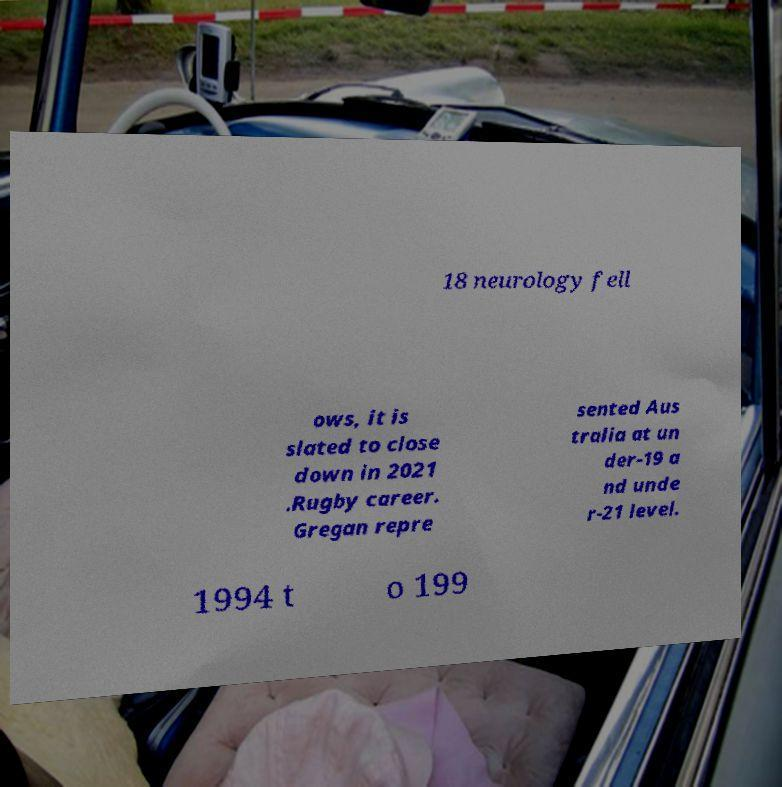Could you assist in decoding the text presented in this image and type it out clearly? 18 neurology fell ows, it is slated to close down in 2021 .Rugby career. Gregan repre sented Aus tralia at un der-19 a nd unde r-21 level. 1994 t o 199 